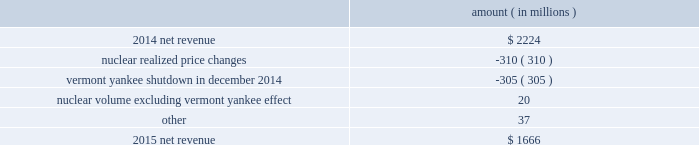Entergy corporation and subsidiaries management 2019s financial discussion and analysis the miso deferral variance is primarily due to the deferral in 2014 of non-fuel miso-related charges , as approved by the lpsc and the mpsc .
The deferral of non-fuel miso-related charges is partially offset in other operation and maintenance expenses .
See note 2 to the financial statements for further discussion of the recovery of non-fuel miso-related charges .
The waterford 3 replacement steam generator provision is due to a regulatory charge of approximately $ 32 million recorded in 2015 related to the uncertainty associated with the resolution of the waterford 3 replacement steam generator project .
See note 2 to the financial statements for a discussion of the waterford 3 replacement steam generator prudence review proceeding .
Entergy wholesale commodities following is an analysis of the change in net revenue comparing 2015 to 2014 .
Amount ( in millions ) .
As shown in the table above , net revenue for entergy wholesale commodities decreased by approximately $ 558 million in 2015 primarily due to : 2022 lower realized wholesale energy prices , primarily due to significantly higher northeast market power prices in 2014 , and lower capacity prices in 2015 ; and 2022 a decrease in net revenue as a result of vermont yankee ceasing power production in december 2014 .
The decrease was partially offset by higher volume in the entergy wholesale commodities nuclear fleet , excluding vermont yankee , resulting from fewer refueling outage days in 2015 as compared to 2014 , partially offset by more unplanned outage days in 2015 as compared to 2014. .
What is the growth rate of net revenue from 2014 to 2015 for entergy wholesale commodities? 
Computations: ((1666 - 2224) / 2224)
Answer: -0.2509. Entergy corporation and subsidiaries management 2019s financial discussion and analysis the volume/weather variance is primarily due to an increase of 1402 gwh , or 1% ( 1 % ) , in billed electricity usage , including an increase in industrial usage and the effect of more favorable weather .
The increase in industrial sales was primarily due to expansion in the chemicals industry and the addition of new customers , partially offset by decreased demand primarily due to extended maintenance outages for existing chemicals customers .
The waterford 3 replacement steam generator provision is due to a regulatory charge of approximately $ 32 million recorded in 2015 related to the uncertainty associated with the resolution of the waterford 3 replacement steam generator project .
See note 2 to the financial statements for a discussion of the waterford 3 replacement steam generator prudence review proceeding .
The miso deferral variance is primarily due to the deferral in 2014 of non-fuel miso-related charges , as approved by the lpsc and the mpsc .
The deferral of non-fuel miso-related charges is partially offset in other operation and maintenance expenses .
See note 2 to the financial statements for further discussion of the recovery of non-fuel miso-related charges .
The louisiana business combination customer credits variance is due to a regulatory liability of $ 107 million recorded by entergy in october 2015 as a result of the entergy gulf states louisiana and entergy louisiana business combination .
Consistent with the terms of the stipulated settlement in the business combination proceeding , electric customers of entergy louisiana will realize customer credits associated with the business combination ; accordingly , in october 2015 , entergy recorded a regulatory liability of $ 107 million ( $ 66 million net-of-tax ) .
See note 2 to the financial statements for further discussion of the business combination and customer credits .
Entergy wholesale commodities following is an analysis of the change in net revenue comparing 2015 to 2014 .
Amount ( in millions ) .
As shown in the table above , net revenue for entergy wholesale commodities decreased by approximately $ 558 million in 2016 primarily due to : 2022 lower realized wholesale energy prices , primarily due to significantly higher northeast market power prices in 2014 , and lower capacity prices in 2015 ; and 2022 a decrease in net revenue as a result of vermont yankee ceasing power production in december 2014 .
The decrease was partially offset by higher volume in the entergy wholesale commodities nuclear fleet , excluding vermont yankee , resulting from fewer refueling outage days in 2015 as compared to 2014 , partially offset by more unplanned outage days in 2015 as compared to 2014. .
What percentage of 2015 net revenue relates to the nuclear volume impact? 
Computations: (20 / 1666)
Answer: 0.012. Entergy corporation and subsidiaries management 2019s financial discussion and analysis the volume/weather variance is primarily due to an increase of 1402 gwh , or 1% ( 1 % ) , in billed electricity usage , including an increase in industrial usage and the effect of more favorable weather .
The increase in industrial sales was primarily due to expansion in the chemicals industry and the addition of new customers , partially offset by decreased demand primarily due to extended maintenance outages for existing chemicals customers .
The waterford 3 replacement steam generator provision is due to a regulatory charge of approximately $ 32 million recorded in 2015 related to the uncertainty associated with the resolution of the waterford 3 replacement steam generator project .
See note 2 to the financial statements for a discussion of the waterford 3 replacement steam generator prudence review proceeding .
The miso deferral variance is primarily due to the deferral in 2014 of non-fuel miso-related charges , as approved by the lpsc and the mpsc .
The deferral of non-fuel miso-related charges is partially offset in other operation and maintenance expenses .
See note 2 to the financial statements for further discussion of the recovery of non-fuel miso-related charges .
The louisiana business combination customer credits variance is due to a regulatory liability of $ 107 million recorded by entergy in october 2015 as a result of the entergy gulf states louisiana and entergy louisiana business combination .
Consistent with the terms of the stipulated settlement in the business combination proceeding , electric customers of entergy louisiana will realize customer credits associated with the business combination ; accordingly , in october 2015 , entergy recorded a regulatory liability of $ 107 million ( $ 66 million net-of-tax ) .
See note 2 to the financial statements for further discussion of the business combination and customer credits .
Entergy wholesale commodities following is an analysis of the change in net revenue comparing 2015 to 2014 .
Amount ( in millions ) .
As shown in the table above , net revenue for entergy wholesale commodities decreased by approximately $ 558 million in 2016 primarily due to : 2022 lower realized wholesale energy prices , primarily due to significantly higher northeast market power prices in 2014 , and lower capacity prices in 2015 ; and 2022 a decrease in net revenue as a result of vermont yankee ceasing power production in december 2014 .
The decrease was partially offset by higher volume in the entergy wholesale commodities nuclear fleet , excluding vermont yankee , resulting from fewer refueling outage days in 2015 as compared to 2014 , partially offset by more unplanned outage days in 2015 as compared to 2014. .
What is the growth rate in net revenue in 2015? 
Computations: ((1666 - 2224) / 2224)
Answer: -0.2509. 